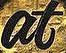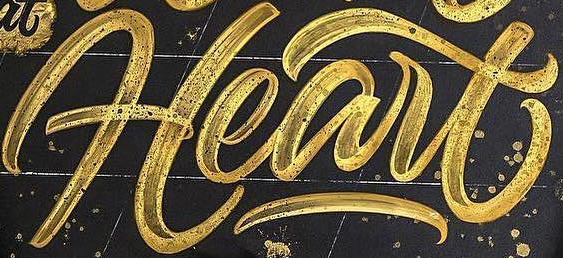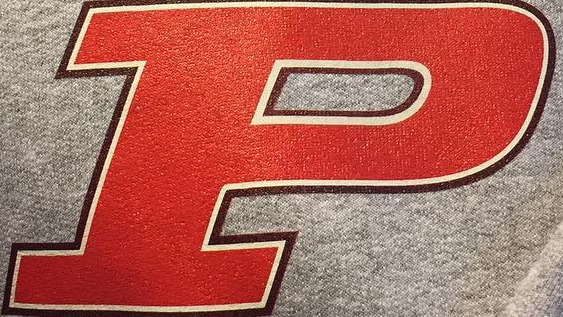Read the text from these images in sequence, separated by a semicolon. at; Heart; P 